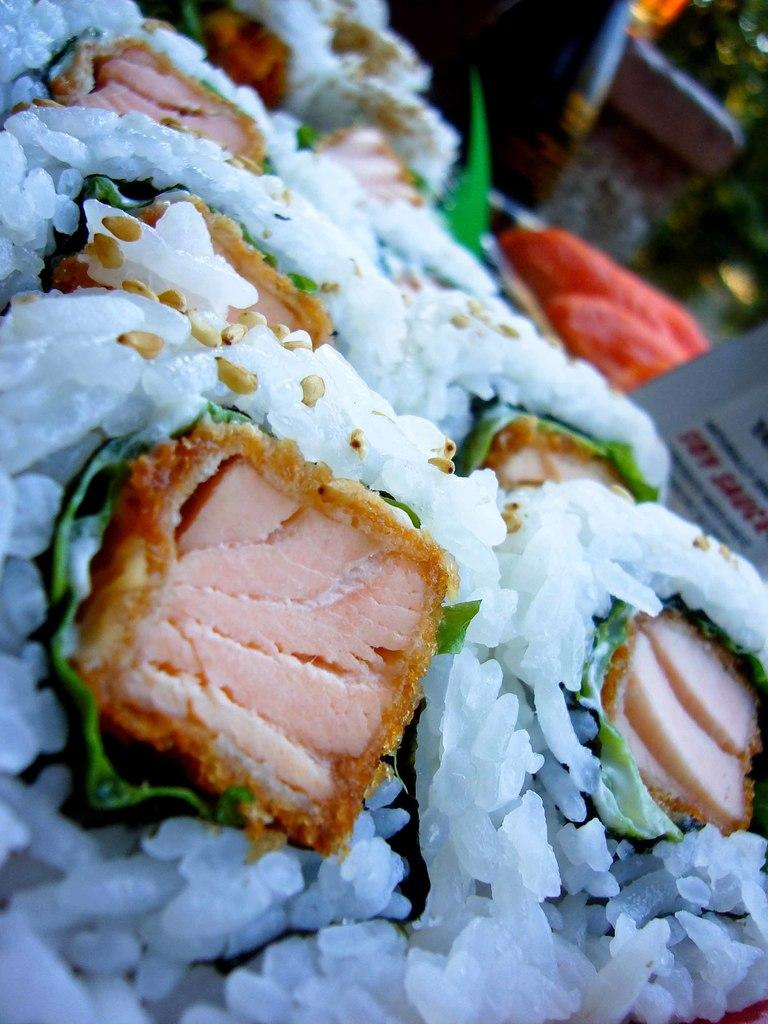What colors can be seen in the food in the image? The food in the image has white, green, and brown colors. What object is visible in the image besides the food? There is a board visible in the image. How would you describe the background of the image? The background of the image appears blurred. How many eyes can be seen on the fan in the image? There is no fan present in the image, so it is not possible to determine the number of eyes on a fan. 